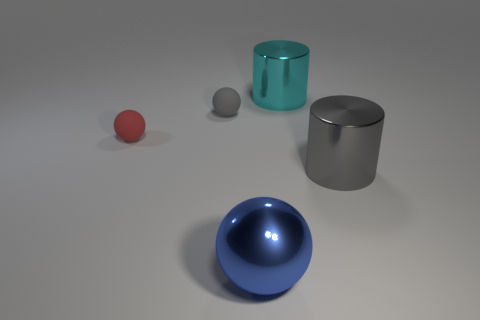What number of big things are either spheres or blue objects?
Ensure brevity in your answer.  1. There is a large metallic thing that is on the left side of the shiny object behind the gray metal cylinder; are there any blue things behind it?
Provide a short and direct response. No. Are there any yellow objects that have the same size as the cyan metal cylinder?
Provide a short and direct response. No. What is the material of the gray cylinder that is the same size as the blue metal sphere?
Make the answer very short. Metal. Is the size of the gray rubber sphere the same as the metal cylinder that is in front of the small gray matte sphere?
Your answer should be very brief. No. How many shiny objects are either cyan cylinders or balls?
Your response must be concise. 2. How many large blue metallic things have the same shape as the red thing?
Give a very brief answer. 1. There is a shiny cylinder to the right of the large cyan cylinder; is its size the same as the gray thing that is left of the blue metal ball?
Your answer should be compact. No. There is a gray object that is on the right side of the blue sphere; what is its shape?
Provide a short and direct response. Cylinder. There is a large gray thing that is the same shape as the large cyan metallic object; what material is it?
Offer a terse response. Metal. 